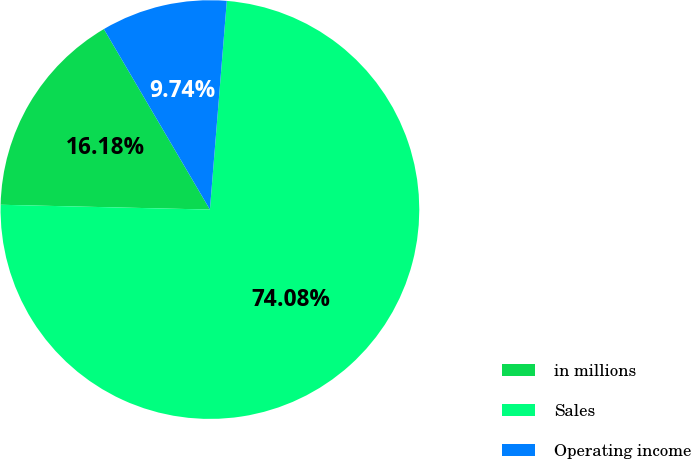Convert chart to OTSL. <chart><loc_0><loc_0><loc_500><loc_500><pie_chart><fcel>in millions<fcel>Sales<fcel>Operating income<nl><fcel>16.18%<fcel>74.08%<fcel>9.74%<nl></chart> 